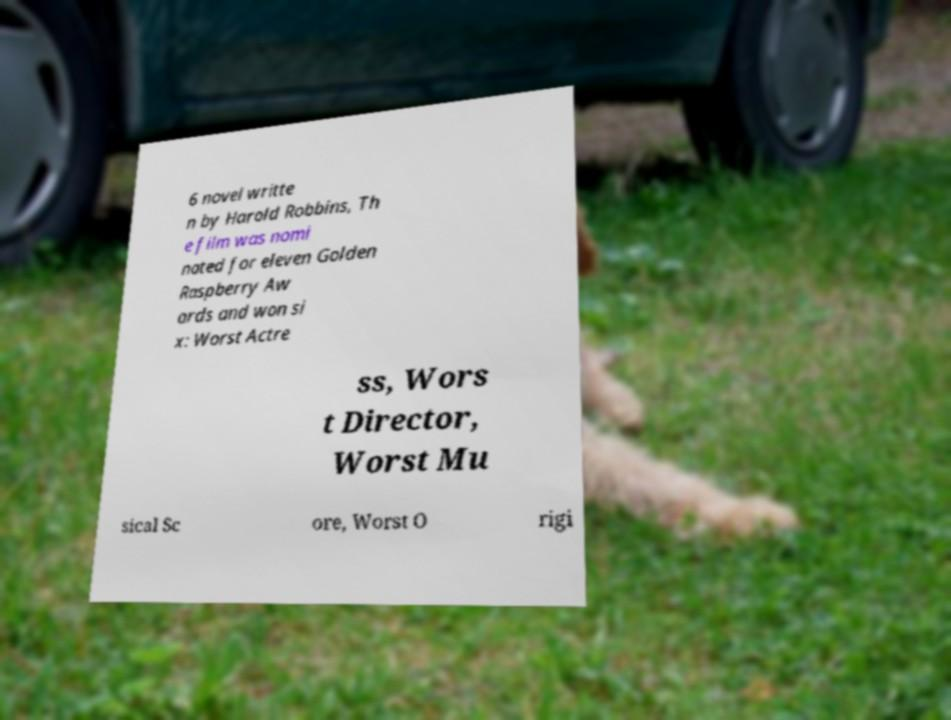For documentation purposes, I need the text within this image transcribed. Could you provide that? 6 novel writte n by Harold Robbins, Th e film was nomi nated for eleven Golden Raspberry Aw ards and won si x: Worst Actre ss, Wors t Director, Worst Mu sical Sc ore, Worst O rigi 